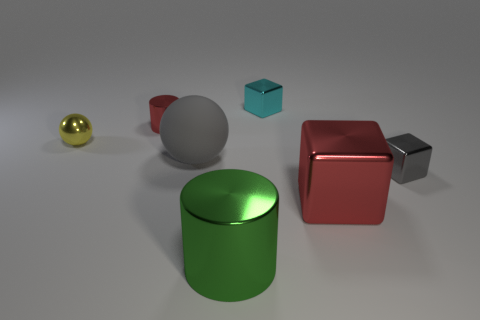Subtract 2 cylinders. How many cylinders are left? 0 Subtract all green cubes. Subtract all blue spheres. How many cubes are left? 3 Add 2 tiny metallic spheres. How many objects exist? 9 Subtract all cylinders. How many objects are left? 5 Add 7 big gray rubber blocks. How many big gray rubber blocks exist? 7 Subtract 1 gray cubes. How many objects are left? 6 Subtract all blue cubes. Subtract all large green cylinders. How many objects are left? 6 Add 2 small metallic balls. How many small metallic balls are left? 3 